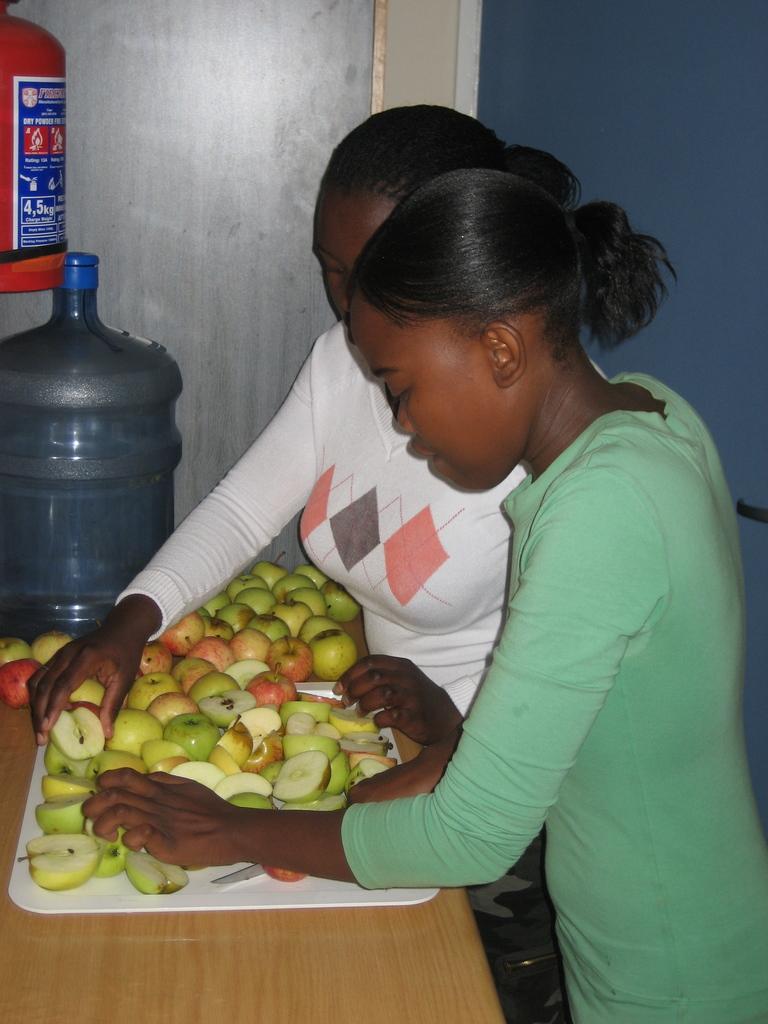Can you describe this image briefly? In this image we can see a two woman and the woman on the right side is cutting apples. This is a wooden table where a plate full of apples kept on it and this is a water kane. There is a fire extinguisher on to the wall which is on the left side. 